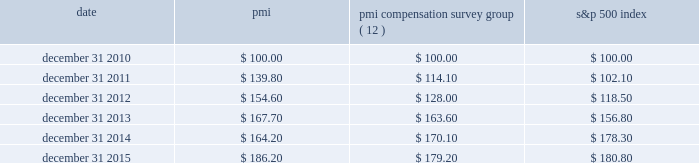Performance graph the graph below compares the cumulative total shareholder return on pmi's common stock with the cumulative total return for the same period of pmi's compensation survey group and the s&p 500 index .
The graph assumes the investment of $ 100 as of december 31 , 2010 , in pmi common stock ( at prices quoted on the new york stock exchange ) and each of the indices as of the market close and reinvestment of dividends on a quarterly basis .
Date pmi pmi compensation survey group ( 12 ) s&p 500 index .
( 1 ) the pmi compensation survey group consists of the following companies with substantial global sales that are direct competitors ; or have similar market capitalization ; or are primarily focused on consumer products ( excluding high technology and financial services ) ; and are companies for which comparative executive compensation data are readily available : bayer ag , british american tobacco p.l.c. , the coca-cola company , diageo plc , glaxosmithkline , heineken n.v. , imperial brands plc ( formerly , imperial tobacco group plc ) , johnson & johnson , mcdonald's corp. , international , inc. , nestl e9 s.a. , novartis ag , pepsico , inc. , pfizer inc. , roche holding ag , unilever nv and plc and vodafone group plc .
( 2 ) on october 1 , 2012 , international , inc .
( nasdaq : mdlz ) , formerly kraft foods inc. , announced that it had completed the spin-off of its north american grocery business , kraft foods group , inc .
( nasdaq : krft ) .
International , inc .
Was retained in the pmi compensation survey group index because of its global footprint .
The pmi compensation survey group index total cumulative return calculation weights international , inc.'s total shareholder return at 65% ( 65 % ) of historical kraft foods inc.'s market capitalization on december 31 , 2010 , based on international , inc.'s initial market capitalization relative to the combined market capitalization of international , inc .
And kraft foods group , inc .
On october 2 , 2012 .
Note : figures are rounded to the nearest $ 0.10. .
What was the difference in percentage cumulative total shareholder return on pmi's common stock versus the s&p 500 index for the five years ended december 31 , 2015? 
Computations: (((186.20 - 100) / 100) - ((180.80 - 100) / 100))
Answer: 0.054. Performance graph the graph below compares the cumulative total shareholder return on pmi's common stock with the cumulative total return for the same period of pmi's compensation survey group and the s&p 500 index .
The graph assumes the investment of $ 100 as of december 31 , 2010 , in pmi common stock ( at prices quoted on the new york stock exchange ) and each of the indices as of the market close and reinvestment of dividends on a quarterly basis .
Date pmi pmi compensation survey group ( 12 ) s&p 500 index .
( 1 ) the pmi compensation survey group consists of the following companies with substantial global sales that are direct competitors ; or have similar market capitalization ; or are primarily focused on consumer products ( excluding high technology and financial services ) ; and are companies for which comparative executive compensation data are readily available : bayer ag , british american tobacco p.l.c. , the coca-cola company , diageo plc , glaxosmithkline , heineken n.v. , imperial brands plc ( formerly , imperial tobacco group plc ) , johnson & johnson , mcdonald's corp. , international , inc. , nestl e9 s.a. , novartis ag , pepsico , inc. , pfizer inc. , roche holding ag , unilever nv and plc and vodafone group plc .
( 2 ) on october 1 , 2012 , international , inc .
( nasdaq : mdlz ) , formerly kraft foods inc. , announced that it had completed the spin-off of its north american grocery business , kraft foods group , inc .
( nasdaq : krft ) .
International , inc .
Was retained in the pmi compensation survey group index because of its global footprint .
The pmi compensation survey group index total cumulative return calculation weights international , inc.'s total shareholder return at 65% ( 65 % ) of historical kraft foods inc.'s market capitalization on december 31 , 2010 , based on international , inc.'s initial market capitalization relative to the combined market capitalization of international , inc .
And kraft foods group , inc .
On october 2 , 2012 .
Note : figures are rounded to the nearest $ 0.10. .
What is the roi of an investment in s&p 500 in 2010 and liquidated in 2011? 
Computations: ((102.10 - 100) / 100)
Answer: 0.021. 